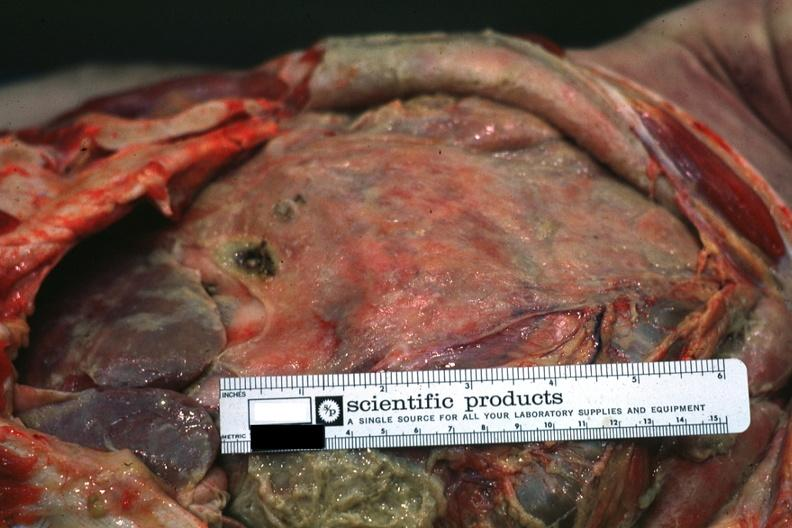why does this image show intestines covered by fibrinopurulent membrane?
Answer the question using a single word or phrase. Due to ruptured peptic ulcer 